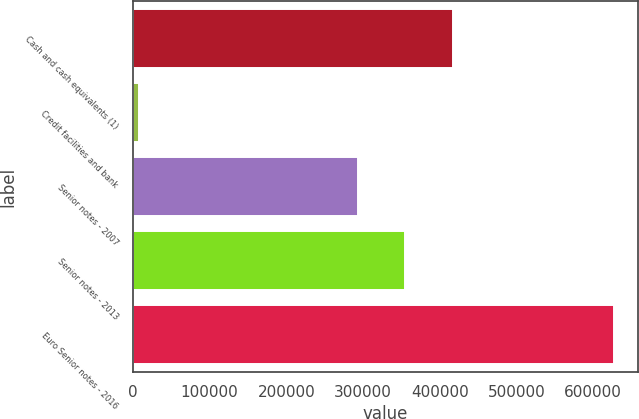Convert chart to OTSL. <chart><loc_0><loc_0><loc_500><loc_500><bar_chart><fcel>Cash and cash equivalents (1)<fcel>Credit facilities and bank<fcel>Senior notes - 2007<fcel>Senior notes - 2013<fcel>Euro Senior notes - 2016<nl><fcel>417190<fcel>7993<fcel>293232<fcel>355211<fcel>627782<nl></chart> 